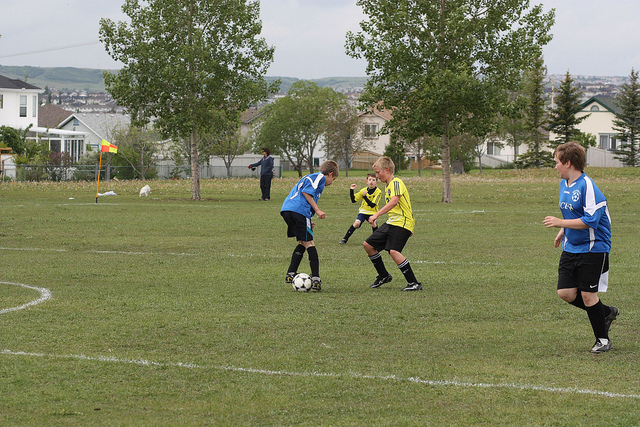<image>What store is in the background? It is unclear what store is in the background. It can be a convenience store or a local store like a Walmart. What store is in the background? There is no store in the background of the image. 